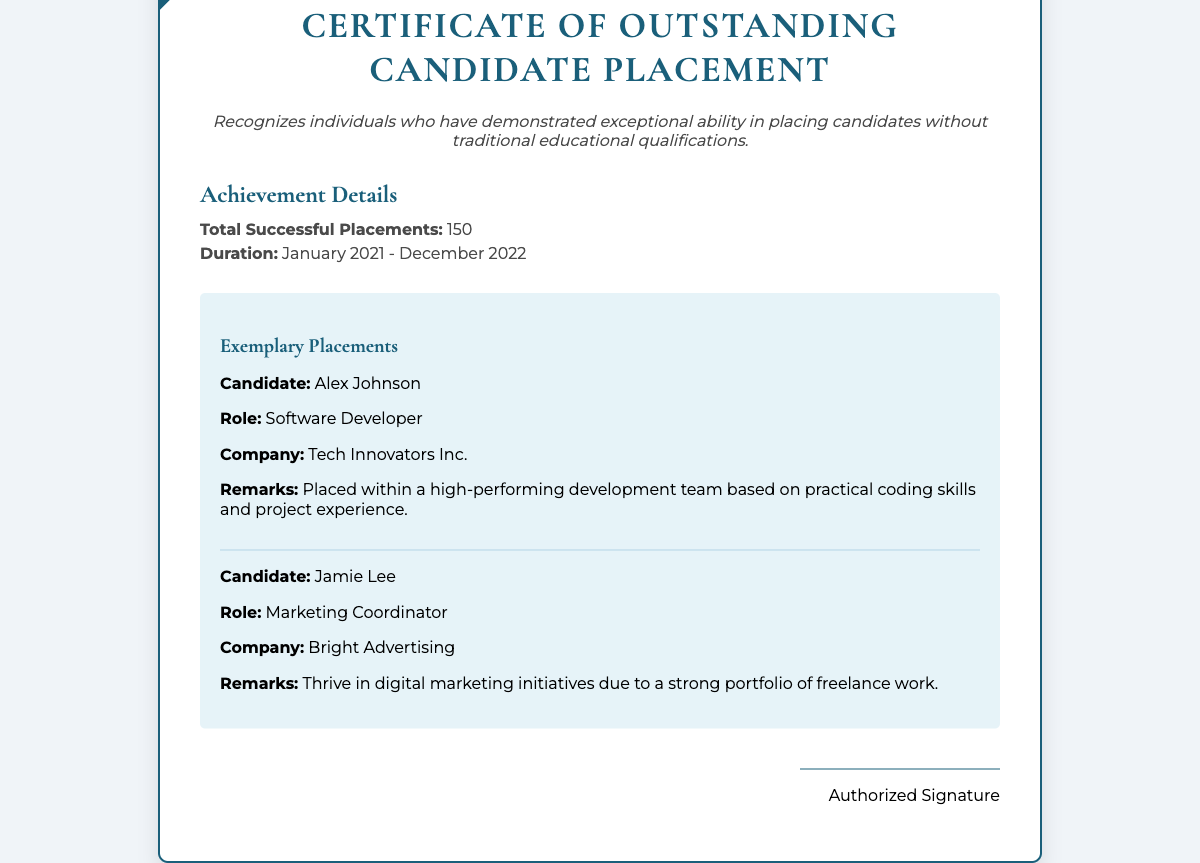what is the title of the certificate? The title of the certificate is displayed prominently at the top of the document.
Answer: Certificate of Outstanding Candidate Placement how many successful placements are recognized? The document specifies the total number of successful placements achieved over the given duration.
Answer: 150 what is the duration for the placements acknowledged in the certificate? The duration refers to the specific time frame during which the successful placements occurred.
Answer: January 2021 - December 2022 who is the first exemplary candidate mentioned? The document lists exemplary placements, specifying the names of the candidates.
Answer: Alex Johnson what role did Jamie Lee secure? The role refers to the position that Jamie Lee was placed in, as stated in the document.
Answer: Marketing Coordinator what company did Alex Johnson join? The document indicates the company where Alex Johnson was placed based on the provided details.
Answer: Tech Innovators Inc what is highlighted as a key aspect of the certificate? The description provides insights into what the certificate signifies and its purpose.
Answer: Exceptional ability in placing candidates without traditional educational qualifications who authorized the certificate? The section at the bottom of the document indicates who provided the authorization.
Answer: Authorized Signature 